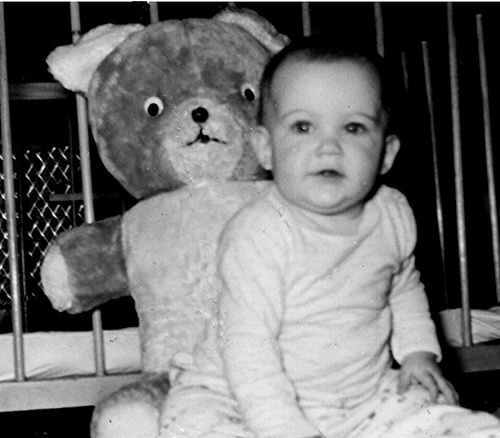Describe the objects in this image and their specific colors. I can see people in white, lightgray, darkgray, gray, and black tones, teddy bear in white, gray, darkgray, lightgray, and black tones, and bed in white, darkgray, lightgray, black, and gray tones in this image. 